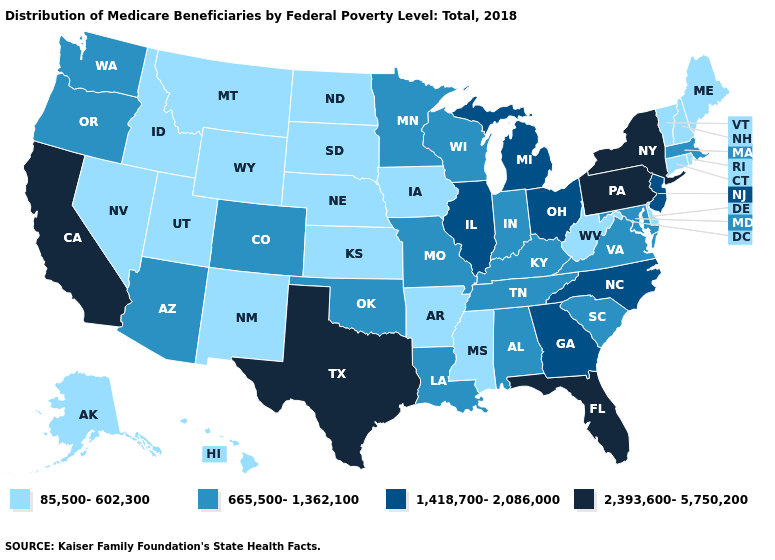Name the states that have a value in the range 85,500-602,300?
Short answer required. Alaska, Arkansas, Connecticut, Delaware, Hawaii, Idaho, Iowa, Kansas, Maine, Mississippi, Montana, Nebraska, Nevada, New Hampshire, New Mexico, North Dakota, Rhode Island, South Dakota, Utah, Vermont, West Virginia, Wyoming. Does the map have missing data?
Answer briefly. No. What is the value of New Mexico?
Write a very short answer. 85,500-602,300. What is the lowest value in the MidWest?
Be succinct. 85,500-602,300. What is the lowest value in the USA?
Answer briefly. 85,500-602,300. What is the lowest value in the USA?
Quick response, please. 85,500-602,300. Does Connecticut have the same value as Maine?
Keep it brief. Yes. What is the value of Georgia?
Concise answer only. 1,418,700-2,086,000. How many symbols are there in the legend?
Short answer required. 4. Which states have the highest value in the USA?
Keep it brief. California, Florida, New York, Pennsylvania, Texas. What is the value of Georgia?
Answer briefly. 1,418,700-2,086,000. Does Delaware have the highest value in the USA?
Concise answer only. No. Is the legend a continuous bar?
Concise answer only. No. Which states have the lowest value in the Northeast?
Short answer required. Connecticut, Maine, New Hampshire, Rhode Island, Vermont. Name the states that have a value in the range 2,393,600-5,750,200?
Give a very brief answer. California, Florida, New York, Pennsylvania, Texas. 